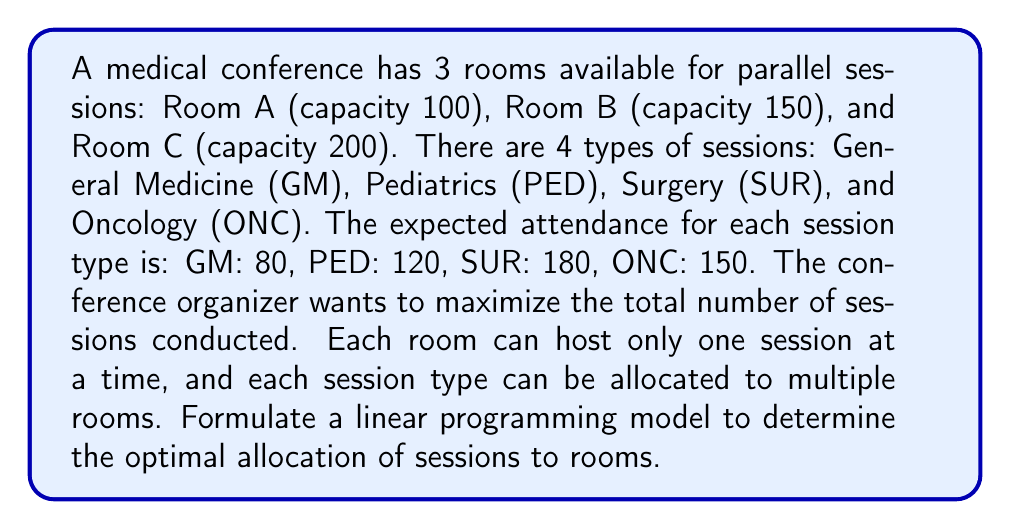Can you solve this math problem? To solve this problem using linear programming, we need to:

1. Define decision variables:
   Let $x_{ij}$ be the number of sessions of type $i$ in room $j$, where
   $i \in \{GM, PED, SUR, ONC\}$ and $j \in \{A, B, C\}$

2. Formulate the objective function:
   Maximize the total number of sessions:
   $$\text{Max } Z = \sum_{i}\sum_{j} x_{ij}$$

3. Define constraints:

   a) Room capacity constraints:
      Room A: $80x_{GM,A} + 120x_{PED,A} + 180x_{SUR,A} + 150x_{ONC,A} \leq 100$
      Room B: $80x_{GM,B} + 120x_{PED,B} + 180x_{SUR,B} + 150x_{ONC,B} \leq 150$
      Room C: $80x_{GM,C} + 120x_{PED,C} + 180x_{SUR,C} + 150x_{ONC,C} \leq 200$

   b) Non-negativity constraints:
      $x_{ij} \geq 0$ for all $i$ and $j$

   c) Integer constraints:
      $x_{ij}$ must be integer for all $i$ and $j$

The complete linear programming model is:

Maximize:
$$Z = x_{GM,A} + x_{GM,B} + x_{GM,C} + x_{PED,A} + x_{PED,B} + x_{PED,C} + x_{SUR,A} + x_{SUR,B} + x_{SUR,C} + x_{ONC,A} + x_{ONC,B} + x_{ONC,C}$$

Subject to:
$$80x_{GM,A} + 120x_{PED,A} + 180x_{SUR,A} + 150x_{ONC,A} \leq 100$$
$$80x_{GM,B} + 120x_{PED,B} + 180x_{SUR,B} + 150x_{ONC,B} \leq 150$$
$$80x_{GM,C} + 120x_{PED,C} + 180x_{SUR,C} + 150x_{ONC,C} \leq 200$$
$$x_{ij} \geq 0 \text{ and integer for all } i \text{ and } j$$

This model can be solved using integer linear programming techniques to find the optimal allocation of sessions to rooms.
Answer: Maximize $Z = \sum_{i}\sum_{j} x_{ij}$ subject to capacity and non-negativity constraints, where $x_{ij}$ represents the number of sessions of type $i$ in room $j$. 